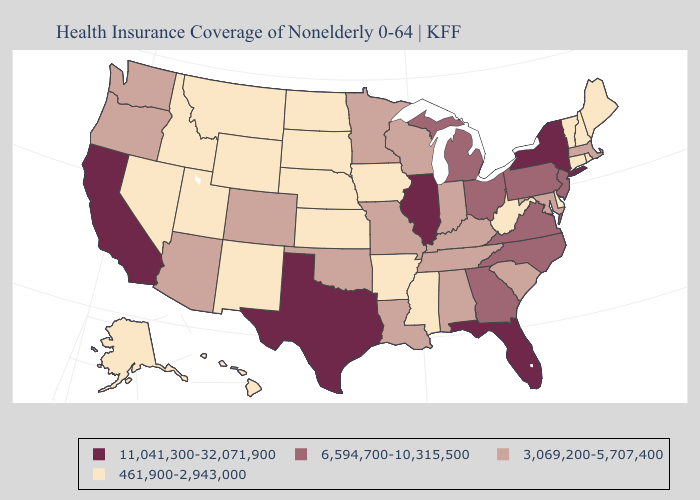Does the first symbol in the legend represent the smallest category?
Be succinct. No. Does the first symbol in the legend represent the smallest category?
Short answer required. No. Name the states that have a value in the range 6,594,700-10,315,500?
Short answer required. Georgia, Michigan, New Jersey, North Carolina, Ohio, Pennsylvania, Virginia. Name the states that have a value in the range 11,041,300-32,071,900?
Answer briefly. California, Florida, Illinois, New York, Texas. What is the lowest value in states that border Vermont?
Concise answer only. 461,900-2,943,000. What is the value of Ohio?
Concise answer only. 6,594,700-10,315,500. What is the value of Connecticut?
Give a very brief answer. 461,900-2,943,000. Which states have the highest value in the USA?
Be succinct. California, Florida, Illinois, New York, Texas. Among the states that border New Jersey , does Pennsylvania have the highest value?
Answer briefly. No. What is the highest value in the USA?
Concise answer only. 11,041,300-32,071,900. What is the value of Montana?
Give a very brief answer. 461,900-2,943,000. Name the states that have a value in the range 461,900-2,943,000?
Keep it brief. Alaska, Arkansas, Connecticut, Delaware, Hawaii, Idaho, Iowa, Kansas, Maine, Mississippi, Montana, Nebraska, Nevada, New Hampshire, New Mexico, North Dakota, Rhode Island, South Dakota, Utah, Vermont, West Virginia, Wyoming. What is the highest value in the USA?
Write a very short answer. 11,041,300-32,071,900. What is the value of Maine?
Be succinct. 461,900-2,943,000. Name the states that have a value in the range 11,041,300-32,071,900?
Short answer required. California, Florida, Illinois, New York, Texas. 